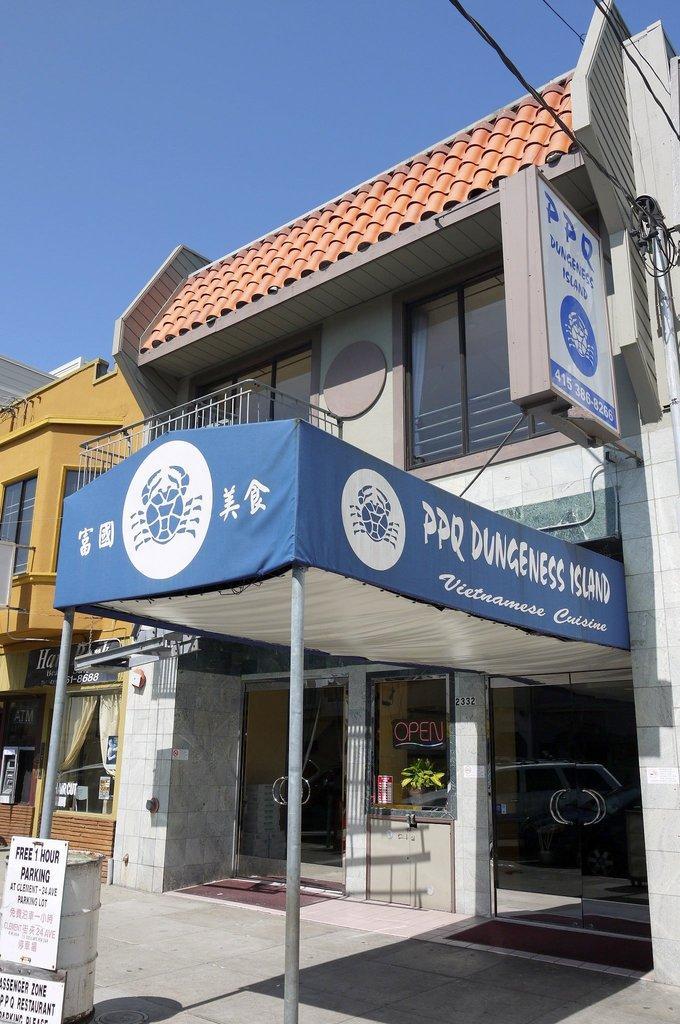Describe this image in one or two sentences. In this picture it looks like a tent in the middle. On the left side I can see few boards, on the right side there is a hoarding, in the background there are buildings. At the top there is the sky. 